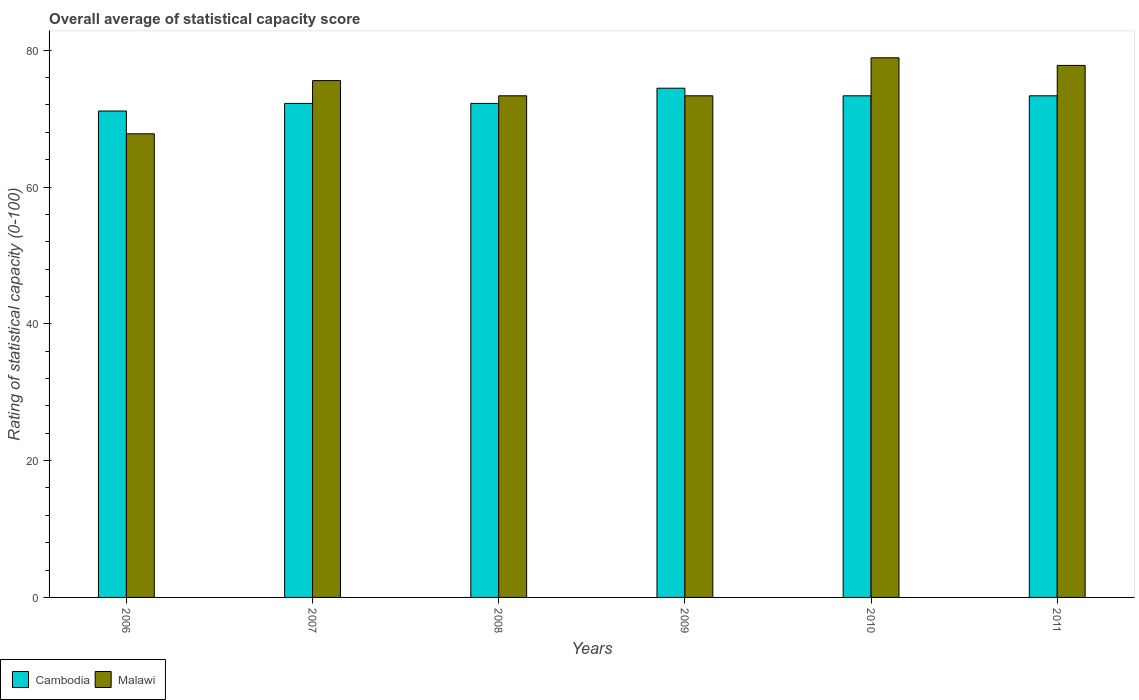How many groups of bars are there?
Provide a succinct answer. 6. Are the number of bars per tick equal to the number of legend labels?
Your response must be concise. Yes. Are the number of bars on each tick of the X-axis equal?
Your answer should be very brief. Yes. What is the rating of statistical capacity in Malawi in 2011?
Offer a terse response. 77.78. Across all years, what is the maximum rating of statistical capacity in Malawi?
Your response must be concise. 78.89. Across all years, what is the minimum rating of statistical capacity in Malawi?
Ensure brevity in your answer.  67.78. What is the total rating of statistical capacity in Cambodia in the graph?
Ensure brevity in your answer.  436.67. What is the difference between the rating of statistical capacity in Malawi in 2007 and that in 2011?
Offer a terse response. -2.22. What is the difference between the rating of statistical capacity in Cambodia in 2007 and the rating of statistical capacity in Malawi in 2009?
Provide a short and direct response. -1.11. What is the average rating of statistical capacity in Cambodia per year?
Offer a very short reply. 72.78. In the year 2007, what is the difference between the rating of statistical capacity in Cambodia and rating of statistical capacity in Malawi?
Ensure brevity in your answer.  -3.33. In how many years, is the rating of statistical capacity in Malawi greater than 56?
Your answer should be very brief. 6. What is the ratio of the rating of statistical capacity in Malawi in 2007 to that in 2008?
Make the answer very short. 1.03. Is the rating of statistical capacity in Malawi in 2007 less than that in 2009?
Offer a very short reply. No. What is the difference between the highest and the second highest rating of statistical capacity in Malawi?
Make the answer very short. 1.11. What is the difference between the highest and the lowest rating of statistical capacity in Malawi?
Your answer should be compact. 11.11. Is the sum of the rating of statistical capacity in Malawi in 2008 and 2011 greater than the maximum rating of statistical capacity in Cambodia across all years?
Provide a short and direct response. Yes. What does the 2nd bar from the left in 2008 represents?
Your response must be concise. Malawi. What does the 2nd bar from the right in 2006 represents?
Make the answer very short. Cambodia. How many years are there in the graph?
Give a very brief answer. 6. Are the values on the major ticks of Y-axis written in scientific E-notation?
Provide a short and direct response. No. Does the graph contain any zero values?
Your answer should be compact. No. Where does the legend appear in the graph?
Offer a very short reply. Bottom left. How are the legend labels stacked?
Your response must be concise. Horizontal. What is the title of the graph?
Ensure brevity in your answer.  Overall average of statistical capacity score. What is the label or title of the X-axis?
Your response must be concise. Years. What is the label or title of the Y-axis?
Offer a terse response. Rating of statistical capacity (0-100). What is the Rating of statistical capacity (0-100) in Cambodia in 2006?
Give a very brief answer. 71.11. What is the Rating of statistical capacity (0-100) in Malawi in 2006?
Provide a succinct answer. 67.78. What is the Rating of statistical capacity (0-100) of Cambodia in 2007?
Your answer should be very brief. 72.22. What is the Rating of statistical capacity (0-100) in Malawi in 2007?
Ensure brevity in your answer.  75.56. What is the Rating of statistical capacity (0-100) in Cambodia in 2008?
Offer a terse response. 72.22. What is the Rating of statistical capacity (0-100) of Malawi in 2008?
Offer a terse response. 73.33. What is the Rating of statistical capacity (0-100) of Cambodia in 2009?
Ensure brevity in your answer.  74.44. What is the Rating of statistical capacity (0-100) of Malawi in 2009?
Ensure brevity in your answer.  73.33. What is the Rating of statistical capacity (0-100) in Cambodia in 2010?
Your answer should be compact. 73.33. What is the Rating of statistical capacity (0-100) of Malawi in 2010?
Give a very brief answer. 78.89. What is the Rating of statistical capacity (0-100) in Cambodia in 2011?
Provide a short and direct response. 73.33. What is the Rating of statistical capacity (0-100) of Malawi in 2011?
Your answer should be very brief. 77.78. Across all years, what is the maximum Rating of statistical capacity (0-100) of Cambodia?
Make the answer very short. 74.44. Across all years, what is the maximum Rating of statistical capacity (0-100) in Malawi?
Your response must be concise. 78.89. Across all years, what is the minimum Rating of statistical capacity (0-100) of Cambodia?
Ensure brevity in your answer.  71.11. Across all years, what is the minimum Rating of statistical capacity (0-100) of Malawi?
Offer a very short reply. 67.78. What is the total Rating of statistical capacity (0-100) of Cambodia in the graph?
Provide a succinct answer. 436.67. What is the total Rating of statistical capacity (0-100) of Malawi in the graph?
Provide a short and direct response. 446.67. What is the difference between the Rating of statistical capacity (0-100) of Cambodia in 2006 and that in 2007?
Your response must be concise. -1.11. What is the difference between the Rating of statistical capacity (0-100) of Malawi in 2006 and that in 2007?
Make the answer very short. -7.78. What is the difference between the Rating of statistical capacity (0-100) of Cambodia in 2006 and that in 2008?
Offer a very short reply. -1.11. What is the difference between the Rating of statistical capacity (0-100) in Malawi in 2006 and that in 2008?
Offer a terse response. -5.56. What is the difference between the Rating of statistical capacity (0-100) of Malawi in 2006 and that in 2009?
Make the answer very short. -5.56. What is the difference between the Rating of statistical capacity (0-100) in Cambodia in 2006 and that in 2010?
Give a very brief answer. -2.22. What is the difference between the Rating of statistical capacity (0-100) in Malawi in 2006 and that in 2010?
Your response must be concise. -11.11. What is the difference between the Rating of statistical capacity (0-100) of Cambodia in 2006 and that in 2011?
Your answer should be compact. -2.22. What is the difference between the Rating of statistical capacity (0-100) in Malawi in 2006 and that in 2011?
Ensure brevity in your answer.  -10. What is the difference between the Rating of statistical capacity (0-100) in Malawi in 2007 and that in 2008?
Your answer should be compact. 2.22. What is the difference between the Rating of statistical capacity (0-100) of Cambodia in 2007 and that in 2009?
Provide a succinct answer. -2.22. What is the difference between the Rating of statistical capacity (0-100) in Malawi in 2007 and that in 2009?
Your answer should be compact. 2.22. What is the difference between the Rating of statistical capacity (0-100) in Cambodia in 2007 and that in 2010?
Provide a succinct answer. -1.11. What is the difference between the Rating of statistical capacity (0-100) of Malawi in 2007 and that in 2010?
Give a very brief answer. -3.33. What is the difference between the Rating of statistical capacity (0-100) of Cambodia in 2007 and that in 2011?
Make the answer very short. -1.11. What is the difference between the Rating of statistical capacity (0-100) of Malawi in 2007 and that in 2011?
Provide a short and direct response. -2.22. What is the difference between the Rating of statistical capacity (0-100) of Cambodia in 2008 and that in 2009?
Your answer should be very brief. -2.22. What is the difference between the Rating of statistical capacity (0-100) of Malawi in 2008 and that in 2009?
Ensure brevity in your answer.  0. What is the difference between the Rating of statistical capacity (0-100) in Cambodia in 2008 and that in 2010?
Your response must be concise. -1.11. What is the difference between the Rating of statistical capacity (0-100) in Malawi in 2008 and that in 2010?
Ensure brevity in your answer.  -5.56. What is the difference between the Rating of statistical capacity (0-100) of Cambodia in 2008 and that in 2011?
Your response must be concise. -1.11. What is the difference between the Rating of statistical capacity (0-100) of Malawi in 2008 and that in 2011?
Your answer should be compact. -4.44. What is the difference between the Rating of statistical capacity (0-100) in Cambodia in 2009 and that in 2010?
Offer a very short reply. 1.11. What is the difference between the Rating of statistical capacity (0-100) of Malawi in 2009 and that in 2010?
Ensure brevity in your answer.  -5.56. What is the difference between the Rating of statistical capacity (0-100) in Malawi in 2009 and that in 2011?
Keep it short and to the point. -4.44. What is the difference between the Rating of statistical capacity (0-100) in Cambodia in 2010 and that in 2011?
Keep it short and to the point. 0. What is the difference between the Rating of statistical capacity (0-100) of Malawi in 2010 and that in 2011?
Give a very brief answer. 1.11. What is the difference between the Rating of statistical capacity (0-100) of Cambodia in 2006 and the Rating of statistical capacity (0-100) of Malawi in 2007?
Provide a short and direct response. -4.44. What is the difference between the Rating of statistical capacity (0-100) in Cambodia in 2006 and the Rating of statistical capacity (0-100) in Malawi in 2008?
Your answer should be compact. -2.22. What is the difference between the Rating of statistical capacity (0-100) of Cambodia in 2006 and the Rating of statistical capacity (0-100) of Malawi in 2009?
Provide a succinct answer. -2.22. What is the difference between the Rating of statistical capacity (0-100) of Cambodia in 2006 and the Rating of statistical capacity (0-100) of Malawi in 2010?
Provide a short and direct response. -7.78. What is the difference between the Rating of statistical capacity (0-100) of Cambodia in 2006 and the Rating of statistical capacity (0-100) of Malawi in 2011?
Your answer should be compact. -6.67. What is the difference between the Rating of statistical capacity (0-100) in Cambodia in 2007 and the Rating of statistical capacity (0-100) in Malawi in 2008?
Your answer should be very brief. -1.11. What is the difference between the Rating of statistical capacity (0-100) in Cambodia in 2007 and the Rating of statistical capacity (0-100) in Malawi in 2009?
Your response must be concise. -1.11. What is the difference between the Rating of statistical capacity (0-100) of Cambodia in 2007 and the Rating of statistical capacity (0-100) of Malawi in 2010?
Give a very brief answer. -6.67. What is the difference between the Rating of statistical capacity (0-100) in Cambodia in 2007 and the Rating of statistical capacity (0-100) in Malawi in 2011?
Make the answer very short. -5.56. What is the difference between the Rating of statistical capacity (0-100) in Cambodia in 2008 and the Rating of statistical capacity (0-100) in Malawi in 2009?
Your response must be concise. -1.11. What is the difference between the Rating of statistical capacity (0-100) of Cambodia in 2008 and the Rating of statistical capacity (0-100) of Malawi in 2010?
Make the answer very short. -6.67. What is the difference between the Rating of statistical capacity (0-100) in Cambodia in 2008 and the Rating of statistical capacity (0-100) in Malawi in 2011?
Your answer should be compact. -5.56. What is the difference between the Rating of statistical capacity (0-100) of Cambodia in 2009 and the Rating of statistical capacity (0-100) of Malawi in 2010?
Your answer should be compact. -4.44. What is the difference between the Rating of statistical capacity (0-100) of Cambodia in 2009 and the Rating of statistical capacity (0-100) of Malawi in 2011?
Your answer should be compact. -3.33. What is the difference between the Rating of statistical capacity (0-100) of Cambodia in 2010 and the Rating of statistical capacity (0-100) of Malawi in 2011?
Your answer should be very brief. -4.44. What is the average Rating of statistical capacity (0-100) in Cambodia per year?
Your response must be concise. 72.78. What is the average Rating of statistical capacity (0-100) of Malawi per year?
Make the answer very short. 74.44. In the year 2006, what is the difference between the Rating of statistical capacity (0-100) in Cambodia and Rating of statistical capacity (0-100) in Malawi?
Your answer should be compact. 3.33. In the year 2008, what is the difference between the Rating of statistical capacity (0-100) in Cambodia and Rating of statistical capacity (0-100) in Malawi?
Your answer should be compact. -1.11. In the year 2010, what is the difference between the Rating of statistical capacity (0-100) of Cambodia and Rating of statistical capacity (0-100) of Malawi?
Your response must be concise. -5.56. In the year 2011, what is the difference between the Rating of statistical capacity (0-100) of Cambodia and Rating of statistical capacity (0-100) of Malawi?
Keep it short and to the point. -4.44. What is the ratio of the Rating of statistical capacity (0-100) in Cambodia in 2006 to that in 2007?
Keep it short and to the point. 0.98. What is the ratio of the Rating of statistical capacity (0-100) of Malawi in 2006 to that in 2007?
Make the answer very short. 0.9. What is the ratio of the Rating of statistical capacity (0-100) in Cambodia in 2006 to that in 2008?
Give a very brief answer. 0.98. What is the ratio of the Rating of statistical capacity (0-100) of Malawi in 2006 to that in 2008?
Ensure brevity in your answer.  0.92. What is the ratio of the Rating of statistical capacity (0-100) in Cambodia in 2006 to that in 2009?
Ensure brevity in your answer.  0.96. What is the ratio of the Rating of statistical capacity (0-100) of Malawi in 2006 to that in 2009?
Give a very brief answer. 0.92. What is the ratio of the Rating of statistical capacity (0-100) in Cambodia in 2006 to that in 2010?
Give a very brief answer. 0.97. What is the ratio of the Rating of statistical capacity (0-100) in Malawi in 2006 to that in 2010?
Ensure brevity in your answer.  0.86. What is the ratio of the Rating of statistical capacity (0-100) of Cambodia in 2006 to that in 2011?
Offer a terse response. 0.97. What is the ratio of the Rating of statistical capacity (0-100) of Malawi in 2006 to that in 2011?
Your answer should be very brief. 0.87. What is the ratio of the Rating of statistical capacity (0-100) in Cambodia in 2007 to that in 2008?
Make the answer very short. 1. What is the ratio of the Rating of statistical capacity (0-100) of Malawi in 2007 to that in 2008?
Your answer should be very brief. 1.03. What is the ratio of the Rating of statistical capacity (0-100) of Cambodia in 2007 to that in 2009?
Keep it short and to the point. 0.97. What is the ratio of the Rating of statistical capacity (0-100) in Malawi in 2007 to that in 2009?
Your answer should be very brief. 1.03. What is the ratio of the Rating of statistical capacity (0-100) in Cambodia in 2007 to that in 2010?
Keep it short and to the point. 0.98. What is the ratio of the Rating of statistical capacity (0-100) in Malawi in 2007 to that in 2010?
Your answer should be compact. 0.96. What is the ratio of the Rating of statistical capacity (0-100) in Malawi in 2007 to that in 2011?
Give a very brief answer. 0.97. What is the ratio of the Rating of statistical capacity (0-100) of Cambodia in 2008 to that in 2009?
Offer a very short reply. 0.97. What is the ratio of the Rating of statistical capacity (0-100) in Malawi in 2008 to that in 2009?
Ensure brevity in your answer.  1. What is the ratio of the Rating of statistical capacity (0-100) in Malawi in 2008 to that in 2010?
Offer a very short reply. 0.93. What is the ratio of the Rating of statistical capacity (0-100) in Malawi in 2008 to that in 2011?
Offer a very short reply. 0.94. What is the ratio of the Rating of statistical capacity (0-100) of Cambodia in 2009 to that in 2010?
Your answer should be compact. 1.02. What is the ratio of the Rating of statistical capacity (0-100) in Malawi in 2009 to that in 2010?
Keep it short and to the point. 0.93. What is the ratio of the Rating of statistical capacity (0-100) in Cambodia in 2009 to that in 2011?
Offer a very short reply. 1.02. What is the ratio of the Rating of statistical capacity (0-100) in Malawi in 2009 to that in 2011?
Give a very brief answer. 0.94. What is the ratio of the Rating of statistical capacity (0-100) in Cambodia in 2010 to that in 2011?
Your answer should be compact. 1. What is the ratio of the Rating of statistical capacity (0-100) of Malawi in 2010 to that in 2011?
Give a very brief answer. 1.01. What is the difference between the highest and the second highest Rating of statistical capacity (0-100) of Cambodia?
Your answer should be very brief. 1.11. What is the difference between the highest and the second highest Rating of statistical capacity (0-100) of Malawi?
Provide a succinct answer. 1.11. What is the difference between the highest and the lowest Rating of statistical capacity (0-100) in Cambodia?
Provide a short and direct response. 3.33. What is the difference between the highest and the lowest Rating of statistical capacity (0-100) of Malawi?
Provide a short and direct response. 11.11. 